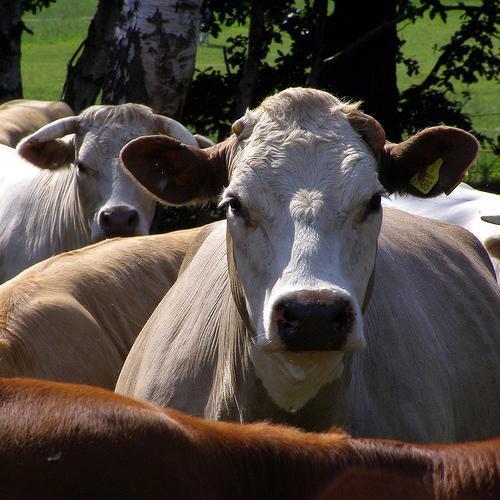How many ears does a cow have?
Give a very brief answer. 2. 